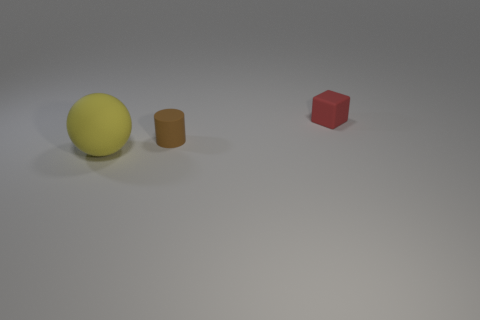Can you describe the texture and material of the objects displayed? Certainly! The yellow sphere has a matte finish indicating a non-reflective, perhaps plastic or painted surface, while the brown cylinder appears to have a slightly rubbery texture. The red cube looks like it might have a smooth or even slightly glossy plastic surface. 